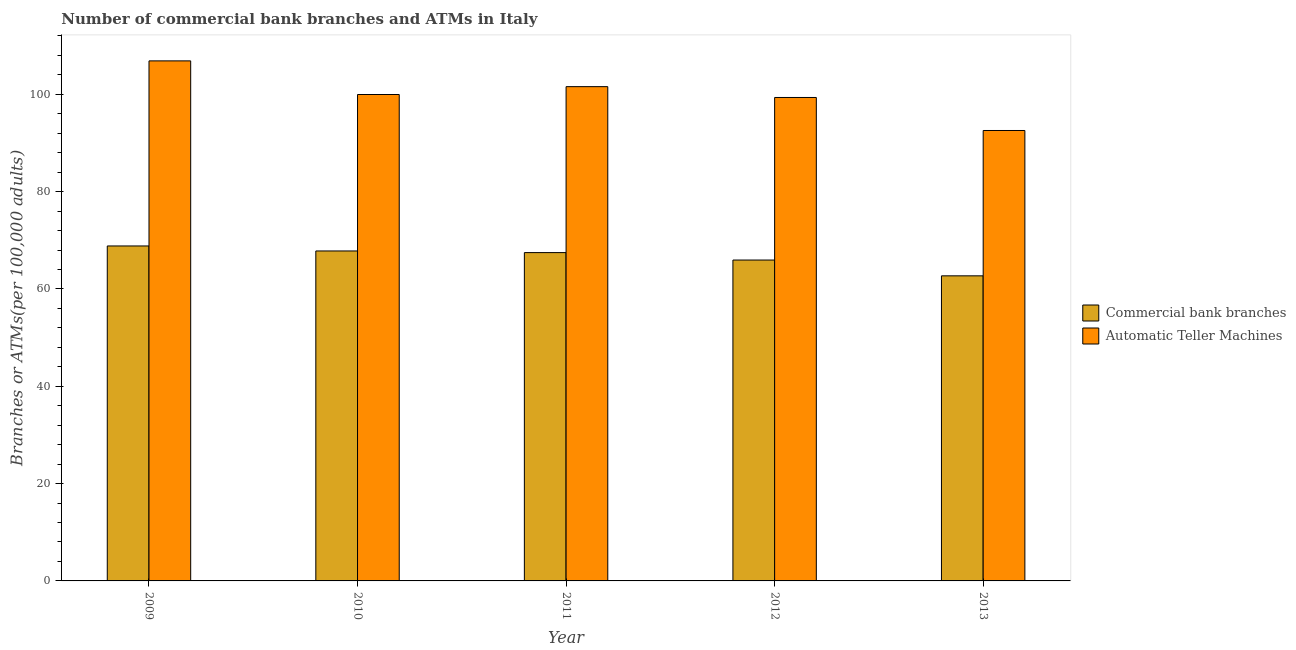Are the number of bars per tick equal to the number of legend labels?
Offer a very short reply. Yes. How many bars are there on the 3rd tick from the left?
Your response must be concise. 2. What is the label of the 5th group of bars from the left?
Your response must be concise. 2013. In how many cases, is the number of bars for a given year not equal to the number of legend labels?
Keep it short and to the point. 0. What is the number of commercal bank branches in 2013?
Provide a short and direct response. 62.7. Across all years, what is the maximum number of atms?
Provide a succinct answer. 106.88. Across all years, what is the minimum number of atms?
Ensure brevity in your answer.  92.57. What is the total number of commercal bank branches in the graph?
Your answer should be compact. 332.78. What is the difference between the number of commercal bank branches in 2009 and that in 2011?
Ensure brevity in your answer.  1.37. What is the difference between the number of atms in 2010 and the number of commercal bank branches in 2013?
Ensure brevity in your answer.  7.39. What is the average number of commercal bank branches per year?
Your answer should be very brief. 66.56. In the year 2010, what is the difference between the number of commercal bank branches and number of atms?
Your response must be concise. 0. What is the ratio of the number of commercal bank branches in 2009 to that in 2012?
Your answer should be compact. 1.04. What is the difference between the highest and the second highest number of atms?
Offer a terse response. 5.3. What is the difference between the highest and the lowest number of commercal bank branches?
Offer a very short reply. 6.14. Is the sum of the number of atms in 2009 and 2011 greater than the maximum number of commercal bank branches across all years?
Provide a short and direct response. Yes. What does the 2nd bar from the left in 2010 represents?
Keep it short and to the point. Automatic Teller Machines. What does the 2nd bar from the right in 2011 represents?
Provide a succinct answer. Commercial bank branches. How many bars are there?
Your answer should be very brief. 10. Are all the bars in the graph horizontal?
Offer a very short reply. No. How many years are there in the graph?
Your response must be concise. 5. What is the difference between two consecutive major ticks on the Y-axis?
Provide a succinct answer. 20. Are the values on the major ticks of Y-axis written in scientific E-notation?
Make the answer very short. No. Does the graph contain any zero values?
Make the answer very short. No. Does the graph contain grids?
Offer a terse response. No. Where does the legend appear in the graph?
Your response must be concise. Center right. How many legend labels are there?
Your response must be concise. 2. How are the legend labels stacked?
Ensure brevity in your answer.  Vertical. What is the title of the graph?
Keep it short and to the point. Number of commercial bank branches and ATMs in Italy. What is the label or title of the Y-axis?
Your response must be concise. Branches or ATMs(per 100,0 adults). What is the Branches or ATMs(per 100,000 adults) in Commercial bank branches in 2009?
Keep it short and to the point. 68.84. What is the Branches or ATMs(per 100,000 adults) in Automatic Teller Machines in 2009?
Provide a short and direct response. 106.88. What is the Branches or ATMs(per 100,000 adults) in Commercial bank branches in 2010?
Keep it short and to the point. 67.81. What is the Branches or ATMs(per 100,000 adults) of Automatic Teller Machines in 2010?
Ensure brevity in your answer.  99.97. What is the Branches or ATMs(per 100,000 adults) in Commercial bank branches in 2011?
Your answer should be very brief. 67.48. What is the Branches or ATMs(per 100,000 adults) of Automatic Teller Machines in 2011?
Your answer should be very brief. 101.58. What is the Branches or ATMs(per 100,000 adults) of Commercial bank branches in 2012?
Ensure brevity in your answer.  65.95. What is the Branches or ATMs(per 100,000 adults) in Automatic Teller Machines in 2012?
Provide a short and direct response. 99.36. What is the Branches or ATMs(per 100,000 adults) in Commercial bank branches in 2013?
Provide a short and direct response. 62.7. What is the Branches or ATMs(per 100,000 adults) in Automatic Teller Machines in 2013?
Your response must be concise. 92.57. Across all years, what is the maximum Branches or ATMs(per 100,000 adults) in Commercial bank branches?
Your answer should be compact. 68.84. Across all years, what is the maximum Branches or ATMs(per 100,000 adults) in Automatic Teller Machines?
Give a very brief answer. 106.88. Across all years, what is the minimum Branches or ATMs(per 100,000 adults) in Commercial bank branches?
Ensure brevity in your answer.  62.7. Across all years, what is the minimum Branches or ATMs(per 100,000 adults) of Automatic Teller Machines?
Give a very brief answer. 92.57. What is the total Branches or ATMs(per 100,000 adults) of Commercial bank branches in the graph?
Give a very brief answer. 332.78. What is the total Branches or ATMs(per 100,000 adults) in Automatic Teller Machines in the graph?
Offer a terse response. 500.37. What is the difference between the Branches or ATMs(per 100,000 adults) of Commercial bank branches in 2009 and that in 2010?
Offer a terse response. 1.03. What is the difference between the Branches or ATMs(per 100,000 adults) of Automatic Teller Machines in 2009 and that in 2010?
Ensure brevity in your answer.  6.91. What is the difference between the Branches or ATMs(per 100,000 adults) in Commercial bank branches in 2009 and that in 2011?
Keep it short and to the point. 1.37. What is the difference between the Branches or ATMs(per 100,000 adults) of Automatic Teller Machines in 2009 and that in 2011?
Ensure brevity in your answer.  5.3. What is the difference between the Branches or ATMs(per 100,000 adults) of Commercial bank branches in 2009 and that in 2012?
Your answer should be very brief. 2.9. What is the difference between the Branches or ATMs(per 100,000 adults) of Automatic Teller Machines in 2009 and that in 2012?
Keep it short and to the point. 7.52. What is the difference between the Branches or ATMs(per 100,000 adults) in Commercial bank branches in 2009 and that in 2013?
Provide a succinct answer. 6.14. What is the difference between the Branches or ATMs(per 100,000 adults) of Automatic Teller Machines in 2009 and that in 2013?
Your answer should be compact. 14.31. What is the difference between the Branches or ATMs(per 100,000 adults) of Commercial bank branches in 2010 and that in 2011?
Your response must be concise. 0.34. What is the difference between the Branches or ATMs(per 100,000 adults) in Automatic Teller Machines in 2010 and that in 2011?
Your response must be concise. -1.62. What is the difference between the Branches or ATMs(per 100,000 adults) in Commercial bank branches in 2010 and that in 2012?
Provide a succinct answer. 1.87. What is the difference between the Branches or ATMs(per 100,000 adults) of Automatic Teller Machines in 2010 and that in 2012?
Ensure brevity in your answer.  0.61. What is the difference between the Branches or ATMs(per 100,000 adults) of Commercial bank branches in 2010 and that in 2013?
Your answer should be compact. 5.11. What is the difference between the Branches or ATMs(per 100,000 adults) in Automatic Teller Machines in 2010 and that in 2013?
Offer a terse response. 7.39. What is the difference between the Branches or ATMs(per 100,000 adults) in Commercial bank branches in 2011 and that in 2012?
Your response must be concise. 1.53. What is the difference between the Branches or ATMs(per 100,000 adults) in Automatic Teller Machines in 2011 and that in 2012?
Ensure brevity in your answer.  2.23. What is the difference between the Branches or ATMs(per 100,000 adults) in Commercial bank branches in 2011 and that in 2013?
Give a very brief answer. 4.78. What is the difference between the Branches or ATMs(per 100,000 adults) in Automatic Teller Machines in 2011 and that in 2013?
Keep it short and to the point. 9.01. What is the difference between the Branches or ATMs(per 100,000 adults) in Commercial bank branches in 2012 and that in 2013?
Make the answer very short. 3.25. What is the difference between the Branches or ATMs(per 100,000 adults) in Automatic Teller Machines in 2012 and that in 2013?
Make the answer very short. 6.79. What is the difference between the Branches or ATMs(per 100,000 adults) of Commercial bank branches in 2009 and the Branches or ATMs(per 100,000 adults) of Automatic Teller Machines in 2010?
Your answer should be very brief. -31.13. What is the difference between the Branches or ATMs(per 100,000 adults) of Commercial bank branches in 2009 and the Branches or ATMs(per 100,000 adults) of Automatic Teller Machines in 2011?
Your answer should be compact. -32.74. What is the difference between the Branches or ATMs(per 100,000 adults) in Commercial bank branches in 2009 and the Branches or ATMs(per 100,000 adults) in Automatic Teller Machines in 2012?
Give a very brief answer. -30.52. What is the difference between the Branches or ATMs(per 100,000 adults) in Commercial bank branches in 2009 and the Branches or ATMs(per 100,000 adults) in Automatic Teller Machines in 2013?
Make the answer very short. -23.73. What is the difference between the Branches or ATMs(per 100,000 adults) of Commercial bank branches in 2010 and the Branches or ATMs(per 100,000 adults) of Automatic Teller Machines in 2011?
Ensure brevity in your answer.  -33.77. What is the difference between the Branches or ATMs(per 100,000 adults) of Commercial bank branches in 2010 and the Branches or ATMs(per 100,000 adults) of Automatic Teller Machines in 2012?
Make the answer very short. -31.55. What is the difference between the Branches or ATMs(per 100,000 adults) in Commercial bank branches in 2010 and the Branches or ATMs(per 100,000 adults) in Automatic Teller Machines in 2013?
Ensure brevity in your answer.  -24.76. What is the difference between the Branches or ATMs(per 100,000 adults) in Commercial bank branches in 2011 and the Branches or ATMs(per 100,000 adults) in Automatic Teller Machines in 2012?
Give a very brief answer. -31.88. What is the difference between the Branches or ATMs(per 100,000 adults) of Commercial bank branches in 2011 and the Branches or ATMs(per 100,000 adults) of Automatic Teller Machines in 2013?
Keep it short and to the point. -25.1. What is the difference between the Branches or ATMs(per 100,000 adults) of Commercial bank branches in 2012 and the Branches or ATMs(per 100,000 adults) of Automatic Teller Machines in 2013?
Provide a short and direct response. -26.63. What is the average Branches or ATMs(per 100,000 adults) of Commercial bank branches per year?
Offer a very short reply. 66.56. What is the average Branches or ATMs(per 100,000 adults) in Automatic Teller Machines per year?
Provide a short and direct response. 100.07. In the year 2009, what is the difference between the Branches or ATMs(per 100,000 adults) of Commercial bank branches and Branches or ATMs(per 100,000 adults) of Automatic Teller Machines?
Ensure brevity in your answer.  -38.04. In the year 2010, what is the difference between the Branches or ATMs(per 100,000 adults) in Commercial bank branches and Branches or ATMs(per 100,000 adults) in Automatic Teller Machines?
Your answer should be very brief. -32.16. In the year 2011, what is the difference between the Branches or ATMs(per 100,000 adults) of Commercial bank branches and Branches or ATMs(per 100,000 adults) of Automatic Teller Machines?
Your answer should be compact. -34.11. In the year 2012, what is the difference between the Branches or ATMs(per 100,000 adults) of Commercial bank branches and Branches or ATMs(per 100,000 adults) of Automatic Teller Machines?
Provide a succinct answer. -33.41. In the year 2013, what is the difference between the Branches or ATMs(per 100,000 adults) in Commercial bank branches and Branches or ATMs(per 100,000 adults) in Automatic Teller Machines?
Offer a terse response. -29.87. What is the ratio of the Branches or ATMs(per 100,000 adults) of Commercial bank branches in 2009 to that in 2010?
Make the answer very short. 1.02. What is the ratio of the Branches or ATMs(per 100,000 adults) of Automatic Teller Machines in 2009 to that in 2010?
Make the answer very short. 1.07. What is the ratio of the Branches or ATMs(per 100,000 adults) of Commercial bank branches in 2009 to that in 2011?
Keep it short and to the point. 1.02. What is the ratio of the Branches or ATMs(per 100,000 adults) in Automatic Teller Machines in 2009 to that in 2011?
Ensure brevity in your answer.  1.05. What is the ratio of the Branches or ATMs(per 100,000 adults) of Commercial bank branches in 2009 to that in 2012?
Ensure brevity in your answer.  1.04. What is the ratio of the Branches or ATMs(per 100,000 adults) of Automatic Teller Machines in 2009 to that in 2012?
Offer a terse response. 1.08. What is the ratio of the Branches or ATMs(per 100,000 adults) in Commercial bank branches in 2009 to that in 2013?
Offer a terse response. 1.1. What is the ratio of the Branches or ATMs(per 100,000 adults) in Automatic Teller Machines in 2009 to that in 2013?
Give a very brief answer. 1.15. What is the ratio of the Branches or ATMs(per 100,000 adults) in Commercial bank branches in 2010 to that in 2011?
Give a very brief answer. 1. What is the ratio of the Branches or ATMs(per 100,000 adults) of Automatic Teller Machines in 2010 to that in 2011?
Keep it short and to the point. 0.98. What is the ratio of the Branches or ATMs(per 100,000 adults) in Commercial bank branches in 2010 to that in 2012?
Your answer should be compact. 1.03. What is the ratio of the Branches or ATMs(per 100,000 adults) in Commercial bank branches in 2010 to that in 2013?
Make the answer very short. 1.08. What is the ratio of the Branches or ATMs(per 100,000 adults) of Automatic Teller Machines in 2010 to that in 2013?
Provide a short and direct response. 1.08. What is the ratio of the Branches or ATMs(per 100,000 adults) in Commercial bank branches in 2011 to that in 2012?
Offer a terse response. 1.02. What is the ratio of the Branches or ATMs(per 100,000 adults) of Automatic Teller Machines in 2011 to that in 2012?
Ensure brevity in your answer.  1.02. What is the ratio of the Branches or ATMs(per 100,000 adults) of Commercial bank branches in 2011 to that in 2013?
Provide a succinct answer. 1.08. What is the ratio of the Branches or ATMs(per 100,000 adults) in Automatic Teller Machines in 2011 to that in 2013?
Your response must be concise. 1.1. What is the ratio of the Branches or ATMs(per 100,000 adults) in Commercial bank branches in 2012 to that in 2013?
Provide a succinct answer. 1.05. What is the ratio of the Branches or ATMs(per 100,000 adults) of Automatic Teller Machines in 2012 to that in 2013?
Ensure brevity in your answer.  1.07. What is the difference between the highest and the second highest Branches or ATMs(per 100,000 adults) in Commercial bank branches?
Offer a very short reply. 1.03. What is the difference between the highest and the second highest Branches or ATMs(per 100,000 adults) in Automatic Teller Machines?
Your answer should be very brief. 5.3. What is the difference between the highest and the lowest Branches or ATMs(per 100,000 adults) of Commercial bank branches?
Your answer should be very brief. 6.14. What is the difference between the highest and the lowest Branches or ATMs(per 100,000 adults) in Automatic Teller Machines?
Ensure brevity in your answer.  14.31. 